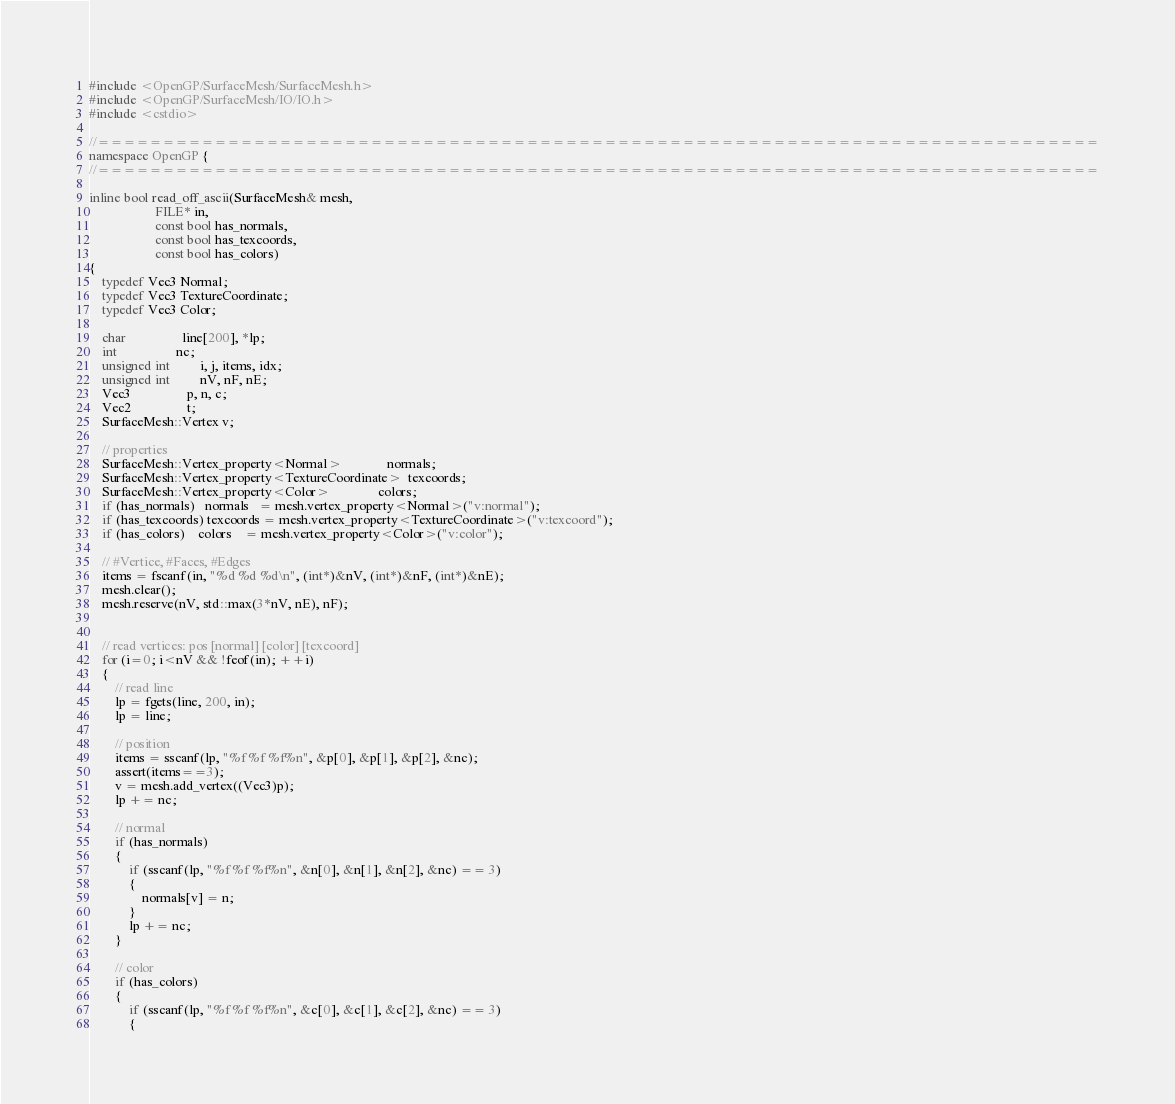<code> <loc_0><loc_0><loc_500><loc_500><_C++_>#include <OpenGP/SurfaceMesh/SurfaceMesh.h>
#include <OpenGP/SurfaceMesh/IO/IO.h>
#include <cstdio>

//=============================================================================
namespace OpenGP {
//=============================================================================

inline bool read_off_ascii(SurfaceMesh& mesh,
                    FILE* in,
                    const bool has_normals,
                    const bool has_texcoords,
                    const bool has_colors)
{
    typedef Vec3 Normal;
    typedef Vec3 TextureCoordinate;
    typedef Vec3 Color;
    
    char                 line[200], *lp;
    int                  nc;
    unsigned int         i, j, items, idx;
    unsigned int         nV, nF, nE;
    Vec3                 p, n, c;
    Vec2                 t;
    SurfaceMesh::Vertex v;
    
    // properties
    SurfaceMesh::Vertex_property<Normal>              normals;
    SurfaceMesh::Vertex_property<TextureCoordinate>  texcoords;
    SurfaceMesh::Vertex_property<Color>               colors;
    if (has_normals)   normals   = mesh.vertex_property<Normal>("v:normal");
    if (has_texcoords) texcoords = mesh.vertex_property<TextureCoordinate>("v:texcoord");
    if (has_colors)    colors    = mesh.vertex_property<Color>("v:color");

    // #Vertice, #Faces, #Edges
    items = fscanf(in, "%d %d %d\n", (int*)&nV, (int*)&nF, (int*)&nE);
    mesh.clear();
    mesh.reserve(nV, std::max(3*nV, nE), nF);


    // read vertices: pos [normal] [color] [texcoord]
    for (i=0; i<nV && !feof(in); ++i)
    {
        // read line
        lp = fgets(line, 200, in);
        lp = line;

        // position
        items = sscanf(lp, "%f %f %f%n", &p[0], &p[1], &p[2], &nc);
        assert(items==3);
        v = mesh.add_vertex((Vec3)p);
        lp += nc;

        // normal
        if (has_normals)
        {
            if (sscanf(lp, "%f %f %f%n", &n[0], &n[1], &n[2], &nc) == 3)
            {
                normals[v] = n;
            }
            lp += nc;
        }

        // color
        if (has_colors)
        {
            if (sscanf(lp, "%f %f %f%n", &c[0], &c[1], &c[2], &nc) == 3)
            {</code> 